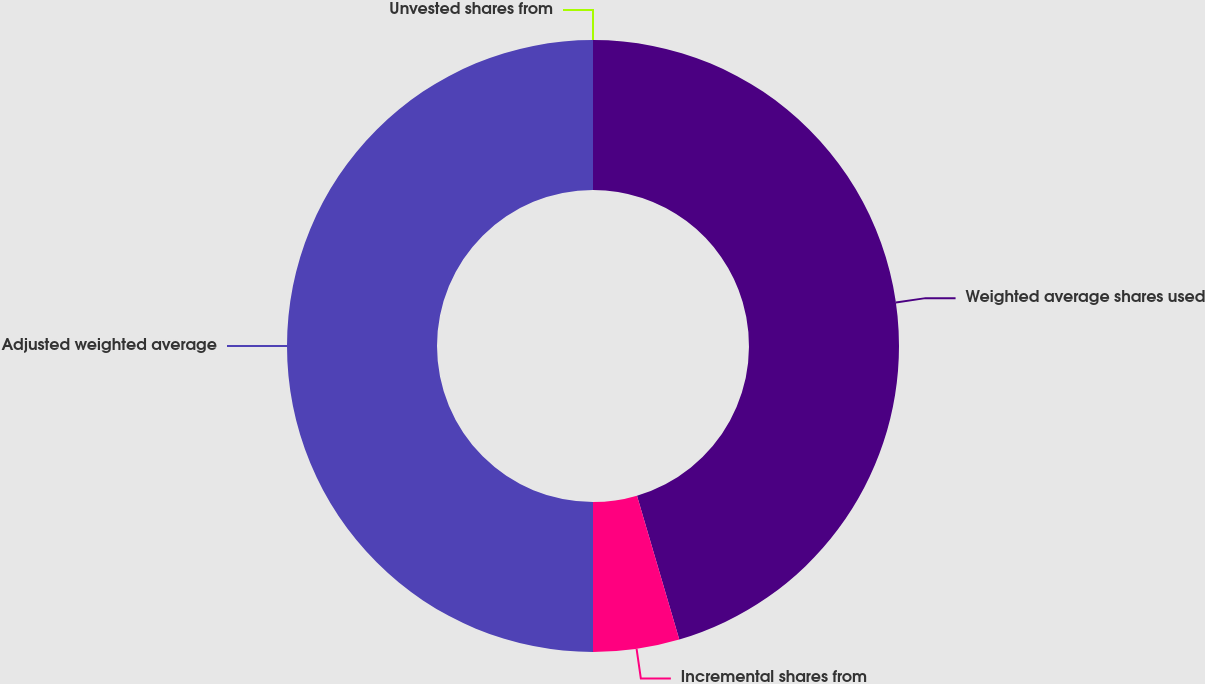Convert chart to OTSL. <chart><loc_0><loc_0><loc_500><loc_500><pie_chart><fcel>Weighted average shares used<fcel>Incremental shares from<fcel>Adjusted weighted average<fcel>Unvested shares from<nl><fcel>45.45%<fcel>4.55%<fcel>50.0%<fcel>0.0%<nl></chart> 